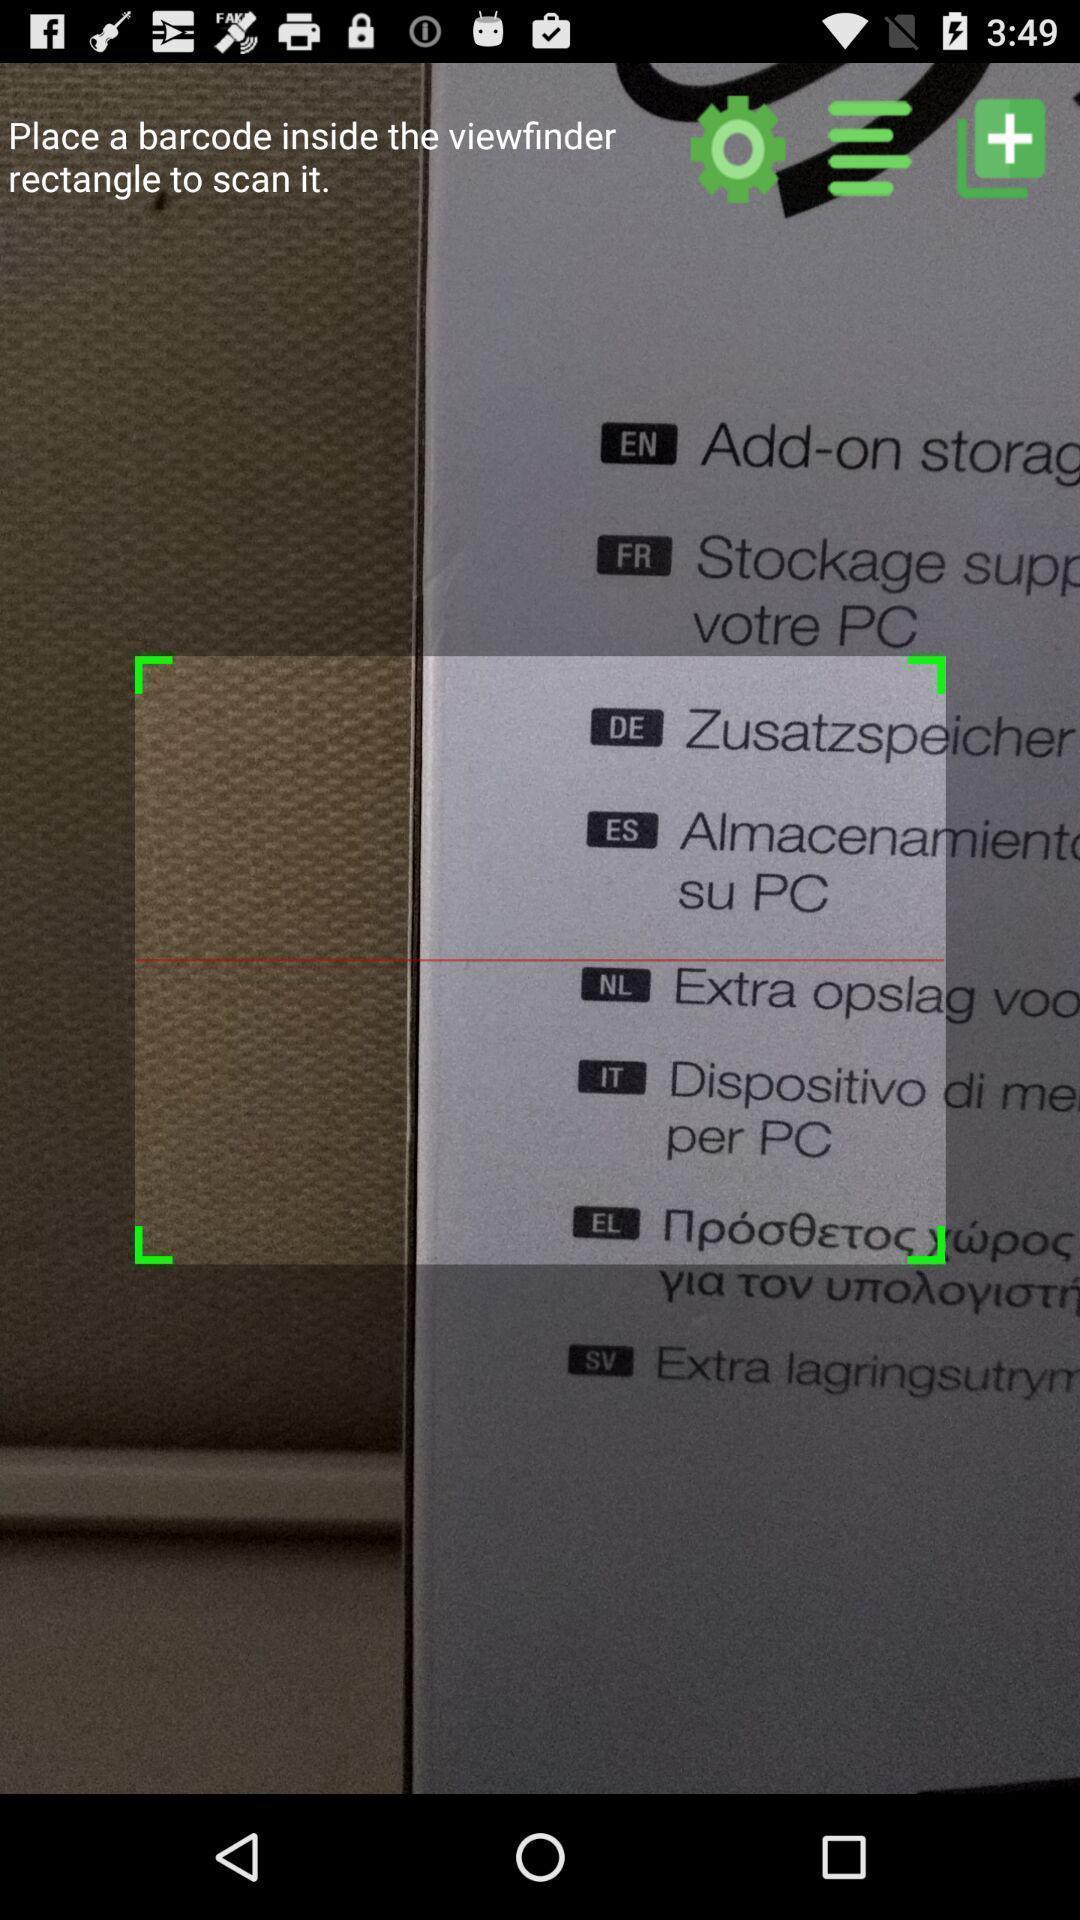Tell me about the visual elements in this screen capture. Page showing scanner on app. 